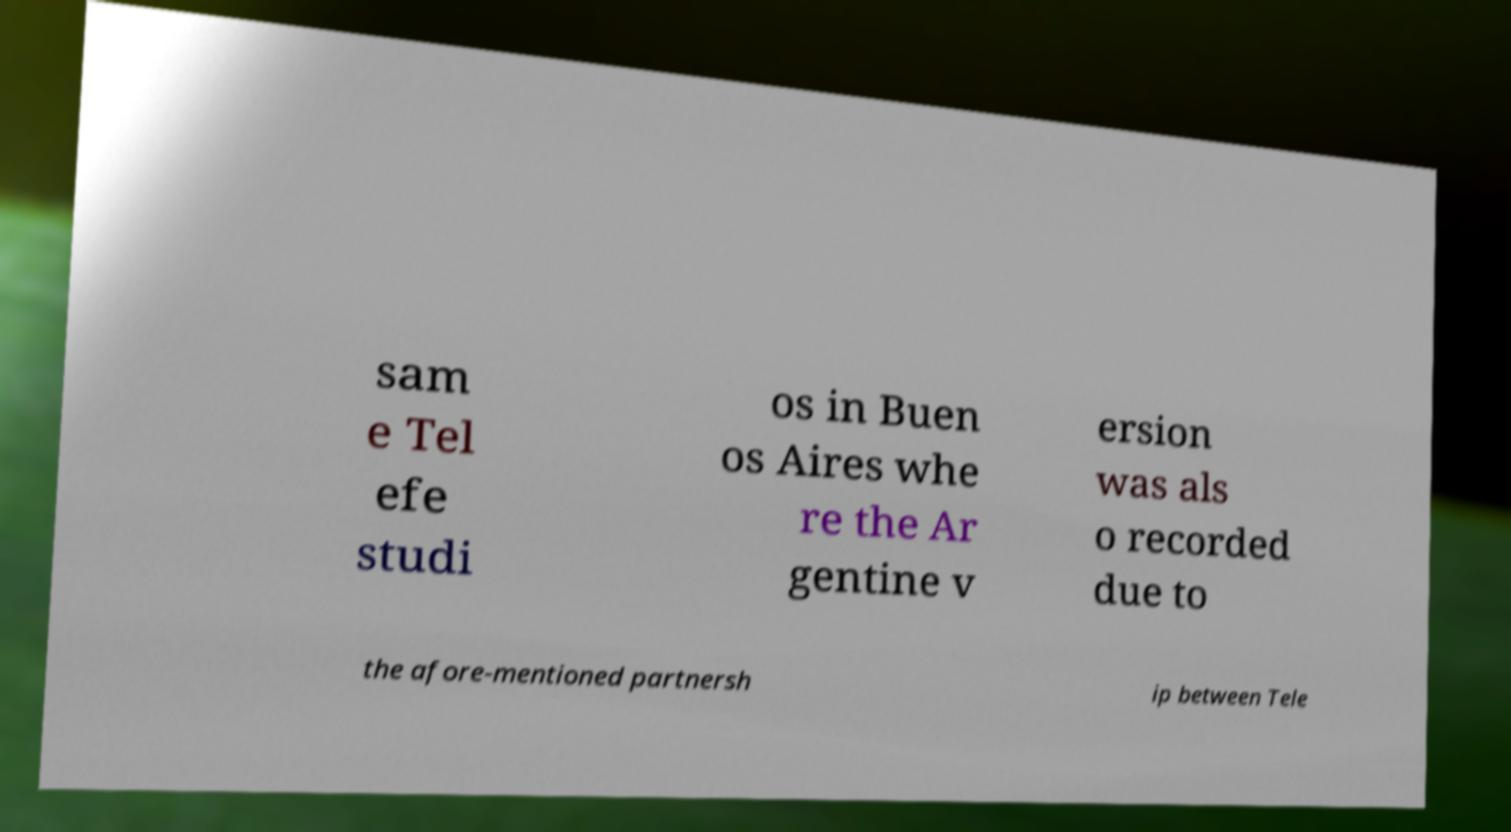For documentation purposes, I need the text within this image transcribed. Could you provide that? sam e Tel efe studi os in Buen os Aires whe re the Ar gentine v ersion was als o recorded due to the afore-mentioned partnersh ip between Tele 